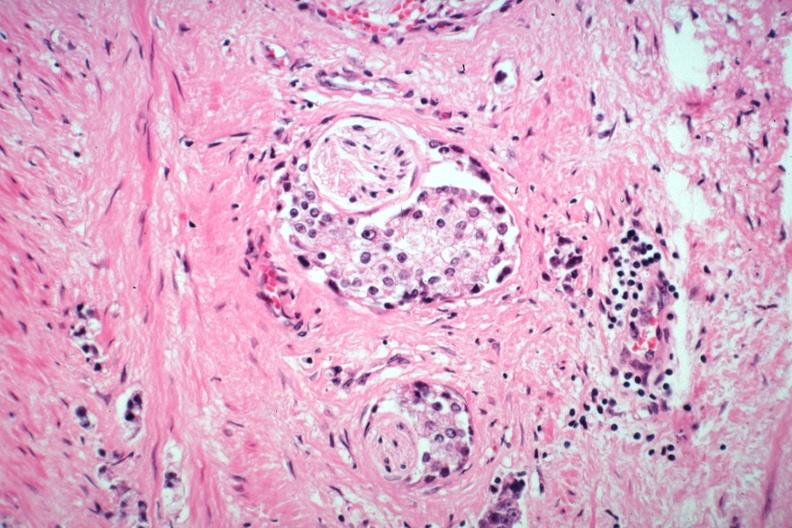what does this image show?
Answer the question using a single word or phrase. Perineural invasion typical prostate carcinoma 